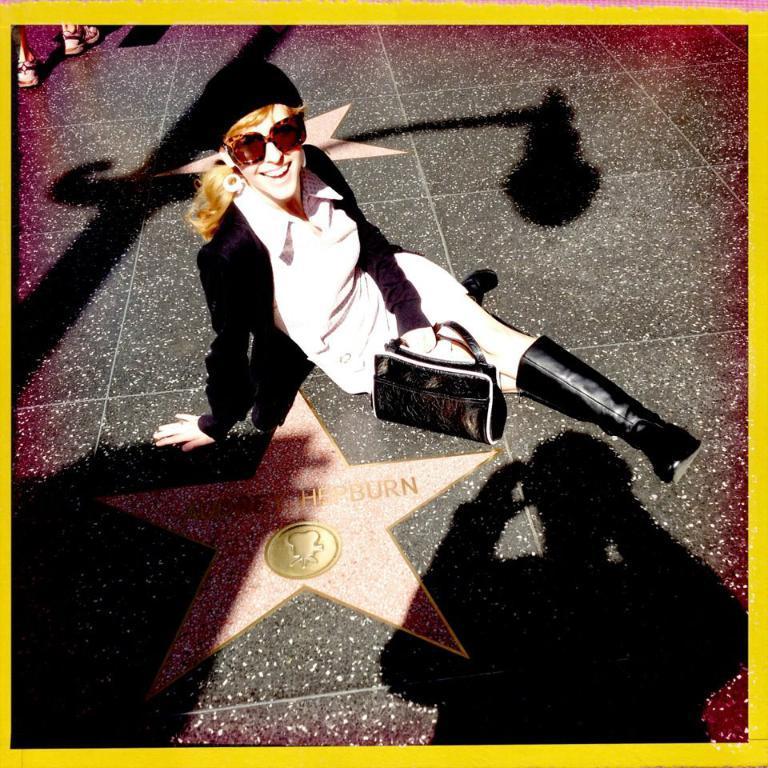How would you summarize this image in a sentence or two? Here a woman is sitting on the floor with a handbag and smiling face. 